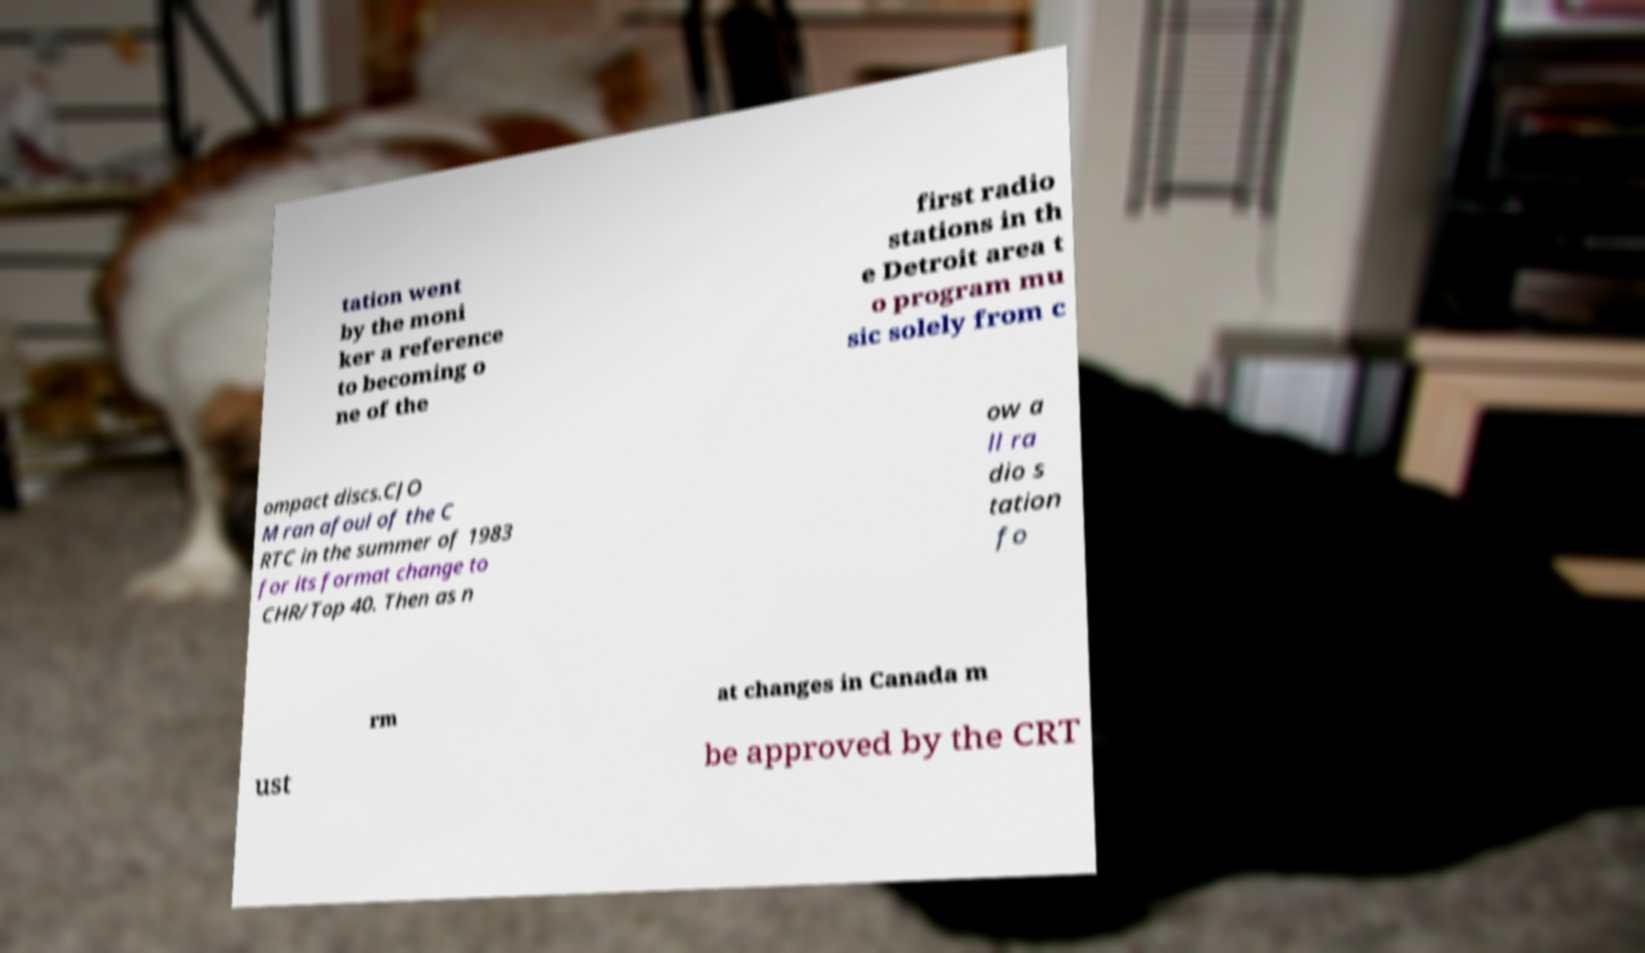What messages or text are displayed in this image? I need them in a readable, typed format. tation went by the moni ker a reference to becoming o ne of the first radio stations in th e Detroit area t o program mu sic solely from c ompact discs.CJO M ran afoul of the C RTC in the summer of 1983 for its format change to CHR/Top 40. Then as n ow a ll ra dio s tation fo rm at changes in Canada m ust be approved by the CRT 